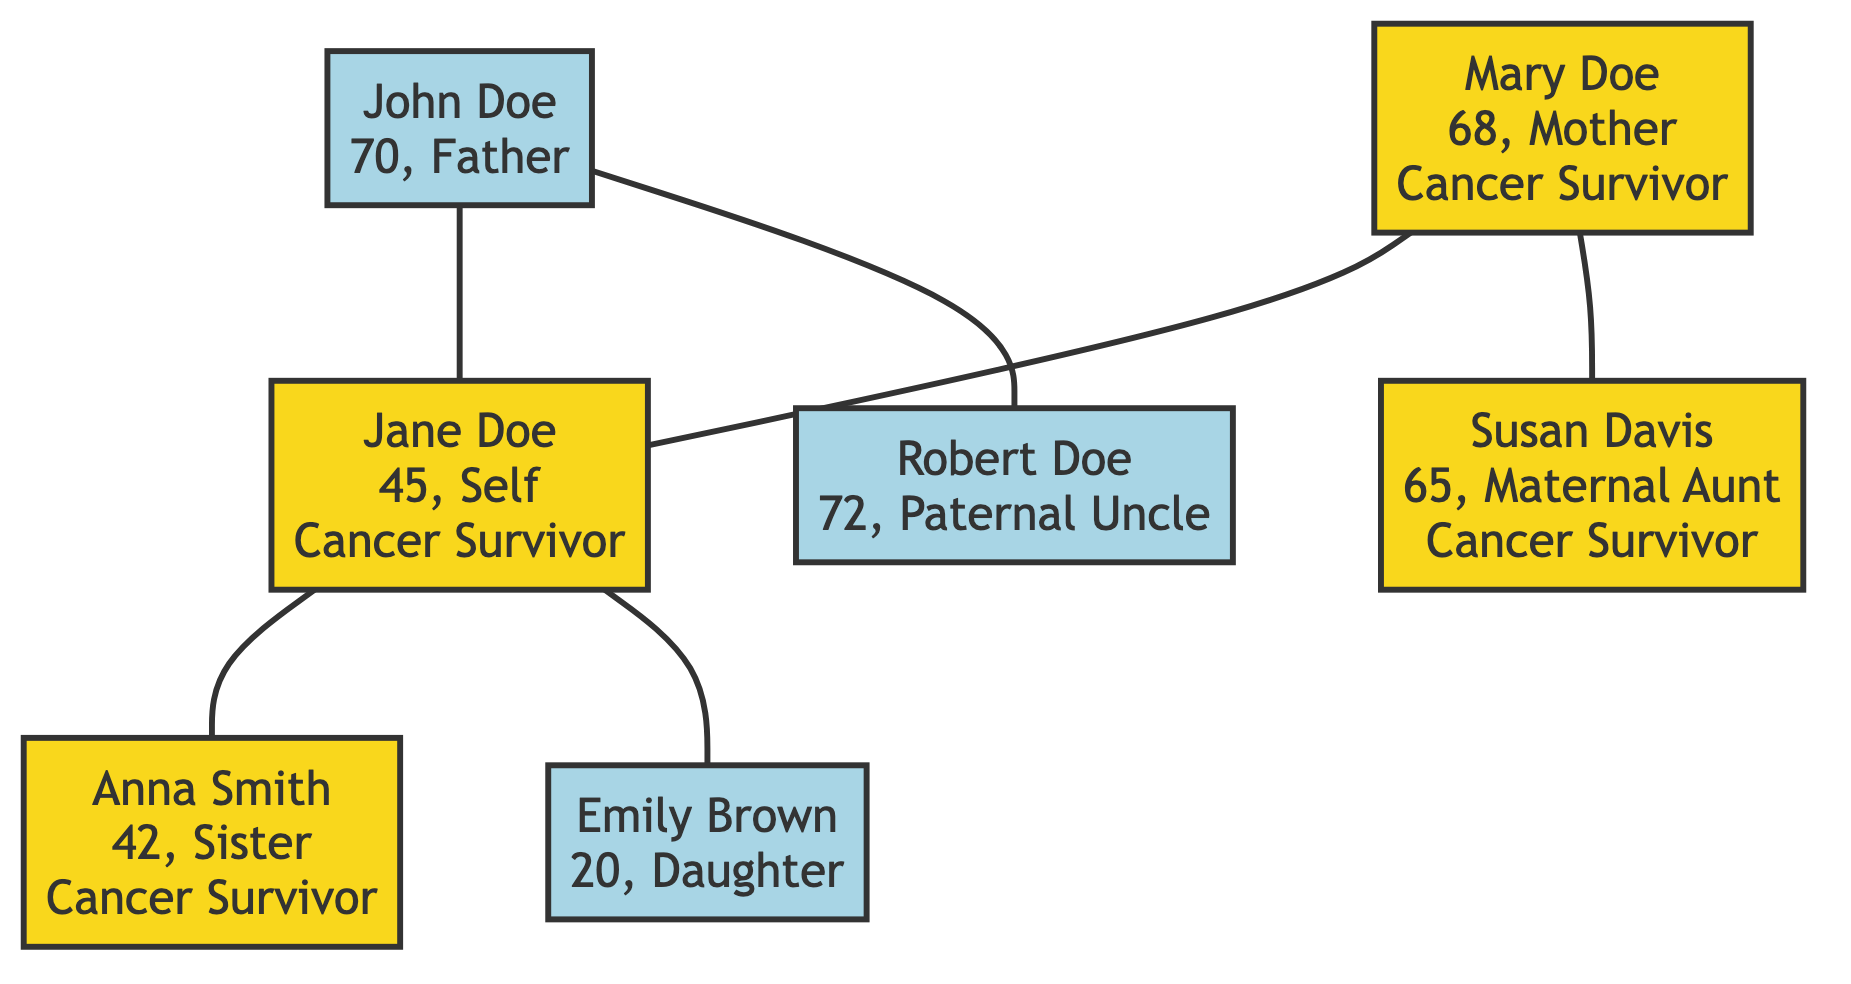What is the age of Jane Doe? The diagram shows Jane Doe in the root node, and her age is explicitly stated as 45.
Answer: 45 How many cancer survivors are in Jane Doe's immediate family? Jane Doe herself, her mother Mary Doe, and her sister Anna Smith are designated as cancer survivors in the diagram. This totals three survivors.
Answer: 3 What type of cancer did Mary Doe survive? The diagram notes Mary Doe as a cancer survivor and specifies that she was diagnosed with cervical cancer.
Answer: Cervical cancer Who is Jane Doe's sister? The diagram indicates that Anna Smith is connected to Jane Doe as her sister.
Answer: Anna Smith How many children does Jane Doe have? The diagram includes a single node for her daughter, Emily Brown, indicating she has one child.
Answer: 1 Which relative has the longest duration of being cancer-free? Among the survivors, Jane Doe's mother, Mary Doe, has been cancer-free for 18 years, which is the longest duration stated in the diagram.
Answer: 18 years What is the relationship between Susan Davis and Jane Doe? The diagram identifies Susan Davis as Jane Doe's maternal aunt, indicating the family relationship clearly.
Answer: Maternal Aunt Is Emily Brown a cancer survivor? The diagram specifies Emily Brown's node without any indication of being a cancer survivor, confirming she is not a survivor.
Answer: No What age is Anna Smith? The node for Anna Smith indicates her age as 42, allowing direct access to this information.
Answer: 42 